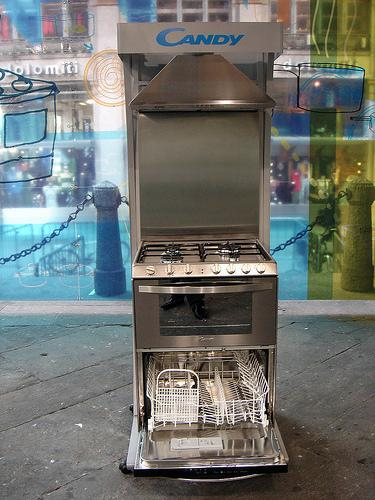Could you please identify and enumerate the main parts of the appliance mentioned in the caption? The appliance has a stove with four burners, air extraction, an oven with a glass door and silver handle, control panel with seven controls, and an open dishwasher with a white dish rack. Describe the full range of controls found on the appliance. The control panel features seven silver color knobs, allowing to control the stove burners, oven settings, and other appliance functions. What is the unusual combination of appliances in the multitask kitchen and washing machine? The unusual combination of appliances is a stove with four burners, an oven, and a dishwasher all in one unit. What is the main kitchen appliance shown in the image, and what can it do? The main kitchen appliance is a multitask kitchen and washing machine, which combines stove with four burners, oven, and dishwasher capabilities. Examine the image and tell me the color of the range and any details about its appearance. The color of the range is gray, black, blue, and silver, featuring stainless steel, silver knobs, a glass oven door, and a metal hood range. What is the brand or logo visible in the image? The logo is for the company "Candy." Which part of the appliance has the word "candy" written on it and in what color? The word "candy" is written in blue on the name of the multitask household appliance. Mention an interesting detail or observation spotted in the image besides the appliance. There is a reflection of a man's shoes visible in the shallow of the pant and shoes image area. Can you please count the total number of stove burners, and describe their arrangement? There are 4 stovetop burners, arranged in a typical square formation. Identify any reflection or lighting effects observed in the image. There is a light reflecting on the range hood, and the reflection of a man's shoes can be seen at another part of the image. Describe the appearance of the control dials on the stove. The control dials are silver and arranged in a long row. Which of the following is inscribed on the multi-task household appliance? a) candy, b) whirlpool, c) kitchenaid a) candy What type of burner does the stove have? The stove has stovetop burners. What are the colors of the range in the image? The colors of the range are gray, black, blue, and silver. What material is the range hood made of? The range hood is made of stainless steel. Point out the details of the dishwasher's basket. The dishwasher's basket is white, plastic-coated, and designed for dishes. What is the appearance of the oven door handle? The oven door handle is silver and long. What is the function of the white utensil rack? The white utensil rack holds and stores kitchen utensils. How many burners does the gas stove have? The gas stove has 4 burners. What appliance combines washing, cooking, and air extraction functionalities? multitask kitchen and washing machine What type of reflection can be seen from the stove's surface? reflection of a man's shoes Describe the position and features of the Candy logo on the appliance. The Candy logo is written in blue and located near the top left corner of the appliance. Find and describe the artwork present in the image. There is a hand drawing of a stove and a pot on a window. Provide a detailed explanation of the stove's control panel. The control panel has seven silver knobs in a row that allow you to control the stove burners. Create an advertising slogan for the multitask kitchen and washing machine appliance. "Revolutionize your kitchen experience with the all-in-one Candy multitask kitchen and washing machine!" What is the function of the white tray visible in the image? The white tray is a detergent dispenser. In a poetic manner, describe the reflections found on the range hood. Glimmering like water under the moon, the range hood captures a light dance, reflecting life's hidden beauties. Is there a bicycle visible in the image? Yes, there is a bicycle laying on the ground outside. 